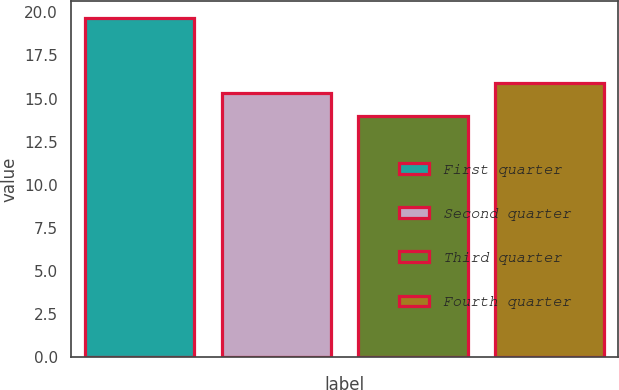Convert chart. <chart><loc_0><loc_0><loc_500><loc_500><bar_chart><fcel>First quarter<fcel>Second quarter<fcel>Third quarter<fcel>Fourth quarter<nl><fcel>19.67<fcel>15.31<fcel>14.01<fcel>15.88<nl></chart> 